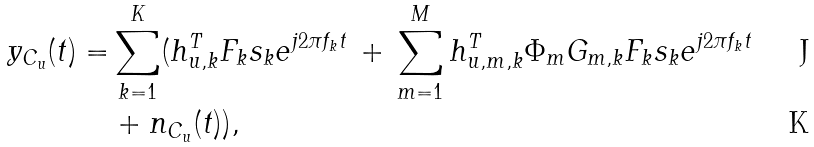<formula> <loc_0><loc_0><loc_500><loc_500>{ y } _ { C _ { u } } ( t ) = & \sum _ { k = 1 } ^ { K } ( { h } _ { u , k } ^ { T } { F } _ { k } { s } _ { k } e ^ { j 2 \pi { f _ { k } } t } \, + \, \sum _ { m = 1 } ^ { M } { h } _ { u , m , k } ^ { T } { \Phi } _ { m } { G } _ { m , k } { F } _ { k } { s } _ { k } e ^ { j 2 \pi { f _ { k } } t } \\ & + n _ { C _ { u } } ( t ) ) ,</formula> 